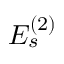<formula> <loc_0><loc_0><loc_500><loc_500>{ E } _ { s } ^ { ( 2 ) }</formula> 